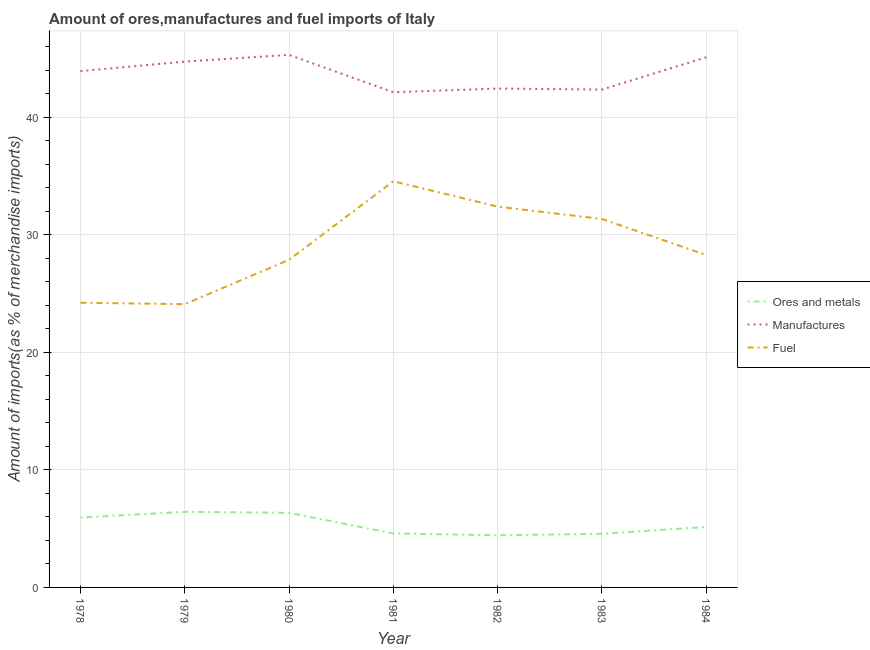How many different coloured lines are there?
Offer a terse response. 3. Is the number of lines equal to the number of legend labels?
Provide a short and direct response. Yes. What is the percentage of fuel imports in 1982?
Ensure brevity in your answer.  32.39. Across all years, what is the maximum percentage of fuel imports?
Keep it short and to the point. 34.54. Across all years, what is the minimum percentage of fuel imports?
Make the answer very short. 24.09. In which year was the percentage of fuel imports minimum?
Ensure brevity in your answer.  1979. What is the total percentage of manufactures imports in the graph?
Keep it short and to the point. 305.9. What is the difference between the percentage of manufactures imports in 1978 and that in 1979?
Your answer should be compact. -0.81. What is the difference between the percentage of manufactures imports in 1983 and the percentage of ores and metals imports in 1980?
Provide a succinct answer. 36. What is the average percentage of manufactures imports per year?
Offer a terse response. 43.7. In the year 1979, what is the difference between the percentage of ores and metals imports and percentage of manufactures imports?
Provide a short and direct response. -38.29. In how many years, is the percentage of manufactures imports greater than 6 %?
Give a very brief answer. 7. What is the ratio of the percentage of fuel imports in 1978 to that in 1982?
Provide a succinct answer. 0.75. Is the percentage of manufactures imports in 1980 less than that in 1982?
Your response must be concise. No. Is the difference between the percentage of ores and metals imports in 1979 and 1982 greater than the difference between the percentage of manufactures imports in 1979 and 1982?
Offer a very short reply. No. What is the difference between the highest and the second highest percentage of manufactures imports?
Provide a short and direct response. 0.2. What is the difference between the highest and the lowest percentage of manufactures imports?
Provide a short and direct response. 3.18. In how many years, is the percentage of fuel imports greater than the average percentage of fuel imports taken over all years?
Offer a very short reply. 3. Is it the case that in every year, the sum of the percentage of ores and metals imports and percentage of manufactures imports is greater than the percentage of fuel imports?
Make the answer very short. Yes. Is the percentage of manufactures imports strictly greater than the percentage of fuel imports over the years?
Your response must be concise. Yes. How many lines are there?
Ensure brevity in your answer.  3. What is the difference between two consecutive major ticks on the Y-axis?
Your answer should be very brief. 10. Are the values on the major ticks of Y-axis written in scientific E-notation?
Your answer should be compact. No. How many legend labels are there?
Ensure brevity in your answer.  3. What is the title of the graph?
Give a very brief answer. Amount of ores,manufactures and fuel imports of Italy. Does "Ages 65 and above" appear as one of the legend labels in the graph?
Your answer should be very brief. No. What is the label or title of the Y-axis?
Your response must be concise. Amount of imports(as % of merchandise imports). What is the Amount of imports(as % of merchandise imports) of Ores and metals in 1978?
Keep it short and to the point. 5.94. What is the Amount of imports(as % of merchandise imports) of Manufactures in 1978?
Offer a very short reply. 43.91. What is the Amount of imports(as % of merchandise imports) of Fuel in 1978?
Offer a terse response. 24.22. What is the Amount of imports(as % of merchandise imports) in Ores and metals in 1979?
Provide a succinct answer. 6.43. What is the Amount of imports(as % of merchandise imports) in Manufactures in 1979?
Your response must be concise. 44.72. What is the Amount of imports(as % of merchandise imports) of Fuel in 1979?
Keep it short and to the point. 24.09. What is the Amount of imports(as % of merchandise imports) of Ores and metals in 1980?
Your answer should be very brief. 6.34. What is the Amount of imports(as % of merchandise imports) of Manufactures in 1980?
Give a very brief answer. 45.29. What is the Amount of imports(as % of merchandise imports) of Fuel in 1980?
Ensure brevity in your answer.  27.86. What is the Amount of imports(as % of merchandise imports) of Ores and metals in 1981?
Provide a short and direct response. 4.59. What is the Amount of imports(as % of merchandise imports) in Manufactures in 1981?
Offer a very short reply. 42.11. What is the Amount of imports(as % of merchandise imports) in Fuel in 1981?
Offer a very short reply. 34.54. What is the Amount of imports(as % of merchandise imports) of Ores and metals in 1982?
Give a very brief answer. 4.43. What is the Amount of imports(as % of merchandise imports) in Manufactures in 1982?
Your answer should be very brief. 42.43. What is the Amount of imports(as % of merchandise imports) in Fuel in 1982?
Offer a very short reply. 32.39. What is the Amount of imports(as % of merchandise imports) in Ores and metals in 1983?
Your answer should be compact. 4.56. What is the Amount of imports(as % of merchandise imports) in Manufactures in 1983?
Your answer should be compact. 42.34. What is the Amount of imports(as % of merchandise imports) in Fuel in 1983?
Keep it short and to the point. 31.34. What is the Amount of imports(as % of merchandise imports) of Ores and metals in 1984?
Provide a succinct answer. 5.15. What is the Amount of imports(as % of merchandise imports) in Manufactures in 1984?
Your answer should be very brief. 45.09. What is the Amount of imports(as % of merchandise imports) in Fuel in 1984?
Your answer should be very brief. 28.27. Across all years, what is the maximum Amount of imports(as % of merchandise imports) of Ores and metals?
Provide a short and direct response. 6.43. Across all years, what is the maximum Amount of imports(as % of merchandise imports) in Manufactures?
Provide a succinct answer. 45.29. Across all years, what is the maximum Amount of imports(as % of merchandise imports) of Fuel?
Your answer should be compact. 34.54. Across all years, what is the minimum Amount of imports(as % of merchandise imports) in Ores and metals?
Your answer should be very brief. 4.43. Across all years, what is the minimum Amount of imports(as % of merchandise imports) in Manufactures?
Provide a succinct answer. 42.11. Across all years, what is the minimum Amount of imports(as % of merchandise imports) in Fuel?
Keep it short and to the point. 24.09. What is the total Amount of imports(as % of merchandise imports) of Ores and metals in the graph?
Your answer should be very brief. 37.44. What is the total Amount of imports(as % of merchandise imports) of Manufactures in the graph?
Your response must be concise. 305.9. What is the total Amount of imports(as % of merchandise imports) in Fuel in the graph?
Make the answer very short. 202.7. What is the difference between the Amount of imports(as % of merchandise imports) in Ores and metals in 1978 and that in 1979?
Provide a succinct answer. -0.49. What is the difference between the Amount of imports(as % of merchandise imports) in Manufactures in 1978 and that in 1979?
Your answer should be very brief. -0.81. What is the difference between the Amount of imports(as % of merchandise imports) in Fuel in 1978 and that in 1979?
Keep it short and to the point. 0.13. What is the difference between the Amount of imports(as % of merchandise imports) of Ores and metals in 1978 and that in 1980?
Provide a succinct answer. -0.4. What is the difference between the Amount of imports(as % of merchandise imports) in Manufactures in 1978 and that in 1980?
Offer a very short reply. -1.38. What is the difference between the Amount of imports(as % of merchandise imports) of Fuel in 1978 and that in 1980?
Your answer should be compact. -3.65. What is the difference between the Amount of imports(as % of merchandise imports) of Ores and metals in 1978 and that in 1981?
Ensure brevity in your answer.  1.35. What is the difference between the Amount of imports(as % of merchandise imports) of Manufactures in 1978 and that in 1981?
Provide a succinct answer. 1.8. What is the difference between the Amount of imports(as % of merchandise imports) in Fuel in 1978 and that in 1981?
Your answer should be compact. -10.33. What is the difference between the Amount of imports(as % of merchandise imports) in Ores and metals in 1978 and that in 1982?
Offer a very short reply. 1.51. What is the difference between the Amount of imports(as % of merchandise imports) of Manufactures in 1978 and that in 1982?
Give a very brief answer. 1.48. What is the difference between the Amount of imports(as % of merchandise imports) of Fuel in 1978 and that in 1982?
Your answer should be very brief. -8.17. What is the difference between the Amount of imports(as % of merchandise imports) in Ores and metals in 1978 and that in 1983?
Your answer should be very brief. 1.38. What is the difference between the Amount of imports(as % of merchandise imports) in Manufactures in 1978 and that in 1983?
Your response must be concise. 1.57. What is the difference between the Amount of imports(as % of merchandise imports) of Fuel in 1978 and that in 1983?
Keep it short and to the point. -7.12. What is the difference between the Amount of imports(as % of merchandise imports) in Ores and metals in 1978 and that in 1984?
Provide a succinct answer. 0.79. What is the difference between the Amount of imports(as % of merchandise imports) in Manufactures in 1978 and that in 1984?
Your response must be concise. -1.18. What is the difference between the Amount of imports(as % of merchandise imports) in Fuel in 1978 and that in 1984?
Make the answer very short. -4.06. What is the difference between the Amount of imports(as % of merchandise imports) of Ores and metals in 1979 and that in 1980?
Provide a succinct answer. 0.09. What is the difference between the Amount of imports(as % of merchandise imports) of Manufactures in 1979 and that in 1980?
Ensure brevity in your answer.  -0.57. What is the difference between the Amount of imports(as % of merchandise imports) in Fuel in 1979 and that in 1980?
Keep it short and to the point. -3.77. What is the difference between the Amount of imports(as % of merchandise imports) of Ores and metals in 1979 and that in 1981?
Give a very brief answer. 1.84. What is the difference between the Amount of imports(as % of merchandise imports) in Manufactures in 1979 and that in 1981?
Ensure brevity in your answer.  2.61. What is the difference between the Amount of imports(as % of merchandise imports) of Fuel in 1979 and that in 1981?
Provide a short and direct response. -10.45. What is the difference between the Amount of imports(as % of merchandise imports) of Ores and metals in 1979 and that in 1982?
Offer a very short reply. 2. What is the difference between the Amount of imports(as % of merchandise imports) in Manufactures in 1979 and that in 1982?
Offer a very short reply. 2.29. What is the difference between the Amount of imports(as % of merchandise imports) of Fuel in 1979 and that in 1982?
Your answer should be very brief. -8.3. What is the difference between the Amount of imports(as % of merchandise imports) of Ores and metals in 1979 and that in 1983?
Your answer should be very brief. 1.87. What is the difference between the Amount of imports(as % of merchandise imports) of Manufactures in 1979 and that in 1983?
Your response must be concise. 2.38. What is the difference between the Amount of imports(as % of merchandise imports) in Fuel in 1979 and that in 1983?
Offer a very short reply. -7.25. What is the difference between the Amount of imports(as % of merchandise imports) of Ores and metals in 1979 and that in 1984?
Your response must be concise. 1.28. What is the difference between the Amount of imports(as % of merchandise imports) in Manufactures in 1979 and that in 1984?
Your answer should be very brief. -0.37. What is the difference between the Amount of imports(as % of merchandise imports) in Fuel in 1979 and that in 1984?
Your response must be concise. -4.18. What is the difference between the Amount of imports(as % of merchandise imports) of Ores and metals in 1980 and that in 1981?
Your answer should be compact. 1.75. What is the difference between the Amount of imports(as % of merchandise imports) of Manufactures in 1980 and that in 1981?
Offer a terse response. 3.18. What is the difference between the Amount of imports(as % of merchandise imports) of Fuel in 1980 and that in 1981?
Offer a terse response. -6.68. What is the difference between the Amount of imports(as % of merchandise imports) in Ores and metals in 1980 and that in 1982?
Offer a very short reply. 1.91. What is the difference between the Amount of imports(as % of merchandise imports) of Manufactures in 1980 and that in 1982?
Provide a short and direct response. 2.87. What is the difference between the Amount of imports(as % of merchandise imports) of Fuel in 1980 and that in 1982?
Your response must be concise. -4.52. What is the difference between the Amount of imports(as % of merchandise imports) of Ores and metals in 1980 and that in 1983?
Your answer should be very brief. 1.78. What is the difference between the Amount of imports(as % of merchandise imports) in Manufactures in 1980 and that in 1983?
Give a very brief answer. 2.95. What is the difference between the Amount of imports(as % of merchandise imports) of Fuel in 1980 and that in 1983?
Your answer should be compact. -3.47. What is the difference between the Amount of imports(as % of merchandise imports) of Ores and metals in 1980 and that in 1984?
Make the answer very short. 1.2. What is the difference between the Amount of imports(as % of merchandise imports) in Manufactures in 1980 and that in 1984?
Provide a short and direct response. 0.2. What is the difference between the Amount of imports(as % of merchandise imports) in Fuel in 1980 and that in 1984?
Provide a short and direct response. -0.41. What is the difference between the Amount of imports(as % of merchandise imports) in Ores and metals in 1981 and that in 1982?
Make the answer very short. 0.16. What is the difference between the Amount of imports(as % of merchandise imports) of Manufactures in 1981 and that in 1982?
Provide a short and direct response. -0.31. What is the difference between the Amount of imports(as % of merchandise imports) of Fuel in 1981 and that in 1982?
Your answer should be very brief. 2.16. What is the difference between the Amount of imports(as % of merchandise imports) in Ores and metals in 1981 and that in 1983?
Ensure brevity in your answer.  0.03. What is the difference between the Amount of imports(as % of merchandise imports) in Manufactures in 1981 and that in 1983?
Your answer should be very brief. -0.23. What is the difference between the Amount of imports(as % of merchandise imports) in Fuel in 1981 and that in 1983?
Offer a very short reply. 3.21. What is the difference between the Amount of imports(as % of merchandise imports) of Ores and metals in 1981 and that in 1984?
Your answer should be compact. -0.55. What is the difference between the Amount of imports(as % of merchandise imports) in Manufactures in 1981 and that in 1984?
Keep it short and to the point. -2.98. What is the difference between the Amount of imports(as % of merchandise imports) in Fuel in 1981 and that in 1984?
Ensure brevity in your answer.  6.27. What is the difference between the Amount of imports(as % of merchandise imports) in Ores and metals in 1982 and that in 1983?
Offer a very short reply. -0.13. What is the difference between the Amount of imports(as % of merchandise imports) of Manufactures in 1982 and that in 1983?
Your answer should be very brief. 0.09. What is the difference between the Amount of imports(as % of merchandise imports) in Fuel in 1982 and that in 1983?
Your answer should be compact. 1.05. What is the difference between the Amount of imports(as % of merchandise imports) of Ores and metals in 1982 and that in 1984?
Provide a short and direct response. -0.71. What is the difference between the Amount of imports(as % of merchandise imports) in Manufactures in 1982 and that in 1984?
Your answer should be very brief. -2.66. What is the difference between the Amount of imports(as % of merchandise imports) of Fuel in 1982 and that in 1984?
Provide a short and direct response. 4.11. What is the difference between the Amount of imports(as % of merchandise imports) in Ores and metals in 1983 and that in 1984?
Offer a very short reply. -0.59. What is the difference between the Amount of imports(as % of merchandise imports) of Manufactures in 1983 and that in 1984?
Ensure brevity in your answer.  -2.75. What is the difference between the Amount of imports(as % of merchandise imports) in Fuel in 1983 and that in 1984?
Offer a terse response. 3.06. What is the difference between the Amount of imports(as % of merchandise imports) in Ores and metals in 1978 and the Amount of imports(as % of merchandise imports) in Manufactures in 1979?
Your response must be concise. -38.78. What is the difference between the Amount of imports(as % of merchandise imports) in Ores and metals in 1978 and the Amount of imports(as % of merchandise imports) in Fuel in 1979?
Provide a short and direct response. -18.15. What is the difference between the Amount of imports(as % of merchandise imports) of Manufactures in 1978 and the Amount of imports(as % of merchandise imports) of Fuel in 1979?
Offer a very short reply. 19.82. What is the difference between the Amount of imports(as % of merchandise imports) in Ores and metals in 1978 and the Amount of imports(as % of merchandise imports) in Manufactures in 1980?
Offer a very short reply. -39.35. What is the difference between the Amount of imports(as % of merchandise imports) in Ores and metals in 1978 and the Amount of imports(as % of merchandise imports) in Fuel in 1980?
Your answer should be compact. -21.92. What is the difference between the Amount of imports(as % of merchandise imports) in Manufactures in 1978 and the Amount of imports(as % of merchandise imports) in Fuel in 1980?
Give a very brief answer. 16.05. What is the difference between the Amount of imports(as % of merchandise imports) in Ores and metals in 1978 and the Amount of imports(as % of merchandise imports) in Manufactures in 1981?
Your response must be concise. -36.17. What is the difference between the Amount of imports(as % of merchandise imports) in Ores and metals in 1978 and the Amount of imports(as % of merchandise imports) in Fuel in 1981?
Offer a very short reply. -28.6. What is the difference between the Amount of imports(as % of merchandise imports) of Manufactures in 1978 and the Amount of imports(as % of merchandise imports) of Fuel in 1981?
Ensure brevity in your answer.  9.37. What is the difference between the Amount of imports(as % of merchandise imports) in Ores and metals in 1978 and the Amount of imports(as % of merchandise imports) in Manufactures in 1982?
Your answer should be very brief. -36.49. What is the difference between the Amount of imports(as % of merchandise imports) in Ores and metals in 1978 and the Amount of imports(as % of merchandise imports) in Fuel in 1982?
Make the answer very short. -26.45. What is the difference between the Amount of imports(as % of merchandise imports) of Manufactures in 1978 and the Amount of imports(as % of merchandise imports) of Fuel in 1982?
Your answer should be very brief. 11.52. What is the difference between the Amount of imports(as % of merchandise imports) of Ores and metals in 1978 and the Amount of imports(as % of merchandise imports) of Manufactures in 1983?
Give a very brief answer. -36.4. What is the difference between the Amount of imports(as % of merchandise imports) of Ores and metals in 1978 and the Amount of imports(as % of merchandise imports) of Fuel in 1983?
Ensure brevity in your answer.  -25.4. What is the difference between the Amount of imports(as % of merchandise imports) of Manufactures in 1978 and the Amount of imports(as % of merchandise imports) of Fuel in 1983?
Give a very brief answer. 12.57. What is the difference between the Amount of imports(as % of merchandise imports) in Ores and metals in 1978 and the Amount of imports(as % of merchandise imports) in Manufactures in 1984?
Provide a short and direct response. -39.15. What is the difference between the Amount of imports(as % of merchandise imports) in Ores and metals in 1978 and the Amount of imports(as % of merchandise imports) in Fuel in 1984?
Offer a very short reply. -22.33. What is the difference between the Amount of imports(as % of merchandise imports) in Manufactures in 1978 and the Amount of imports(as % of merchandise imports) in Fuel in 1984?
Provide a short and direct response. 15.64. What is the difference between the Amount of imports(as % of merchandise imports) of Ores and metals in 1979 and the Amount of imports(as % of merchandise imports) of Manufactures in 1980?
Provide a succinct answer. -38.86. What is the difference between the Amount of imports(as % of merchandise imports) of Ores and metals in 1979 and the Amount of imports(as % of merchandise imports) of Fuel in 1980?
Ensure brevity in your answer.  -21.43. What is the difference between the Amount of imports(as % of merchandise imports) in Manufactures in 1979 and the Amount of imports(as % of merchandise imports) in Fuel in 1980?
Offer a terse response. 16.86. What is the difference between the Amount of imports(as % of merchandise imports) in Ores and metals in 1979 and the Amount of imports(as % of merchandise imports) in Manufactures in 1981?
Provide a short and direct response. -35.68. What is the difference between the Amount of imports(as % of merchandise imports) in Ores and metals in 1979 and the Amount of imports(as % of merchandise imports) in Fuel in 1981?
Offer a terse response. -28.11. What is the difference between the Amount of imports(as % of merchandise imports) of Manufactures in 1979 and the Amount of imports(as % of merchandise imports) of Fuel in 1981?
Provide a short and direct response. 10.18. What is the difference between the Amount of imports(as % of merchandise imports) in Ores and metals in 1979 and the Amount of imports(as % of merchandise imports) in Manufactures in 1982?
Ensure brevity in your answer.  -36. What is the difference between the Amount of imports(as % of merchandise imports) of Ores and metals in 1979 and the Amount of imports(as % of merchandise imports) of Fuel in 1982?
Provide a succinct answer. -25.96. What is the difference between the Amount of imports(as % of merchandise imports) in Manufactures in 1979 and the Amount of imports(as % of merchandise imports) in Fuel in 1982?
Provide a succinct answer. 12.33. What is the difference between the Amount of imports(as % of merchandise imports) of Ores and metals in 1979 and the Amount of imports(as % of merchandise imports) of Manufactures in 1983?
Keep it short and to the point. -35.91. What is the difference between the Amount of imports(as % of merchandise imports) in Ores and metals in 1979 and the Amount of imports(as % of merchandise imports) in Fuel in 1983?
Your response must be concise. -24.91. What is the difference between the Amount of imports(as % of merchandise imports) in Manufactures in 1979 and the Amount of imports(as % of merchandise imports) in Fuel in 1983?
Provide a succinct answer. 13.38. What is the difference between the Amount of imports(as % of merchandise imports) of Ores and metals in 1979 and the Amount of imports(as % of merchandise imports) of Manufactures in 1984?
Your response must be concise. -38.66. What is the difference between the Amount of imports(as % of merchandise imports) of Ores and metals in 1979 and the Amount of imports(as % of merchandise imports) of Fuel in 1984?
Keep it short and to the point. -21.84. What is the difference between the Amount of imports(as % of merchandise imports) in Manufactures in 1979 and the Amount of imports(as % of merchandise imports) in Fuel in 1984?
Provide a succinct answer. 16.45. What is the difference between the Amount of imports(as % of merchandise imports) of Ores and metals in 1980 and the Amount of imports(as % of merchandise imports) of Manufactures in 1981?
Keep it short and to the point. -35.77. What is the difference between the Amount of imports(as % of merchandise imports) in Ores and metals in 1980 and the Amount of imports(as % of merchandise imports) in Fuel in 1981?
Ensure brevity in your answer.  -28.2. What is the difference between the Amount of imports(as % of merchandise imports) of Manufactures in 1980 and the Amount of imports(as % of merchandise imports) of Fuel in 1981?
Provide a short and direct response. 10.75. What is the difference between the Amount of imports(as % of merchandise imports) of Ores and metals in 1980 and the Amount of imports(as % of merchandise imports) of Manufactures in 1982?
Make the answer very short. -36.09. What is the difference between the Amount of imports(as % of merchandise imports) of Ores and metals in 1980 and the Amount of imports(as % of merchandise imports) of Fuel in 1982?
Make the answer very short. -26.04. What is the difference between the Amount of imports(as % of merchandise imports) of Manufactures in 1980 and the Amount of imports(as % of merchandise imports) of Fuel in 1982?
Provide a succinct answer. 12.91. What is the difference between the Amount of imports(as % of merchandise imports) of Ores and metals in 1980 and the Amount of imports(as % of merchandise imports) of Manufactures in 1983?
Keep it short and to the point. -36. What is the difference between the Amount of imports(as % of merchandise imports) of Ores and metals in 1980 and the Amount of imports(as % of merchandise imports) of Fuel in 1983?
Ensure brevity in your answer.  -24.99. What is the difference between the Amount of imports(as % of merchandise imports) in Manufactures in 1980 and the Amount of imports(as % of merchandise imports) in Fuel in 1983?
Keep it short and to the point. 13.96. What is the difference between the Amount of imports(as % of merchandise imports) in Ores and metals in 1980 and the Amount of imports(as % of merchandise imports) in Manufactures in 1984?
Make the answer very short. -38.75. What is the difference between the Amount of imports(as % of merchandise imports) in Ores and metals in 1980 and the Amount of imports(as % of merchandise imports) in Fuel in 1984?
Make the answer very short. -21.93. What is the difference between the Amount of imports(as % of merchandise imports) of Manufactures in 1980 and the Amount of imports(as % of merchandise imports) of Fuel in 1984?
Your answer should be compact. 17.02. What is the difference between the Amount of imports(as % of merchandise imports) of Ores and metals in 1981 and the Amount of imports(as % of merchandise imports) of Manufactures in 1982?
Your answer should be compact. -37.84. What is the difference between the Amount of imports(as % of merchandise imports) of Ores and metals in 1981 and the Amount of imports(as % of merchandise imports) of Fuel in 1982?
Provide a short and direct response. -27.79. What is the difference between the Amount of imports(as % of merchandise imports) in Manufactures in 1981 and the Amount of imports(as % of merchandise imports) in Fuel in 1982?
Ensure brevity in your answer.  9.73. What is the difference between the Amount of imports(as % of merchandise imports) of Ores and metals in 1981 and the Amount of imports(as % of merchandise imports) of Manufactures in 1983?
Make the answer very short. -37.75. What is the difference between the Amount of imports(as % of merchandise imports) in Ores and metals in 1981 and the Amount of imports(as % of merchandise imports) in Fuel in 1983?
Keep it short and to the point. -26.75. What is the difference between the Amount of imports(as % of merchandise imports) of Manufactures in 1981 and the Amount of imports(as % of merchandise imports) of Fuel in 1983?
Keep it short and to the point. 10.78. What is the difference between the Amount of imports(as % of merchandise imports) in Ores and metals in 1981 and the Amount of imports(as % of merchandise imports) in Manufactures in 1984?
Give a very brief answer. -40.5. What is the difference between the Amount of imports(as % of merchandise imports) in Ores and metals in 1981 and the Amount of imports(as % of merchandise imports) in Fuel in 1984?
Your answer should be very brief. -23.68. What is the difference between the Amount of imports(as % of merchandise imports) of Manufactures in 1981 and the Amount of imports(as % of merchandise imports) of Fuel in 1984?
Offer a very short reply. 13.84. What is the difference between the Amount of imports(as % of merchandise imports) of Ores and metals in 1982 and the Amount of imports(as % of merchandise imports) of Manufactures in 1983?
Your answer should be compact. -37.91. What is the difference between the Amount of imports(as % of merchandise imports) in Ores and metals in 1982 and the Amount of imports(as % of merchandise imports) in Fuel in 1983?
Provide a succinct answer. -26.9. What is the difference between the Amount of imports(as % of merchandise imports) in Manufactures in 1982 and the Amount of imports(as % of merchandise imports) in Fuel in 1983?
Keep it short and to the point. 11.09. What is the difference between the Amount of imports(as % of merchandise imports) in Ores and metals in 1982 and the Amount of imports(as % of merchandise imports) in Manufactures in 1984?
Your answer should be compact. -40.66. What is the difference between the Amount of imports(as % of merchandise imports) in Ores and metals in 1982 and the Amount of imports(as % of merchandise imports) in Fuel in 1984?
Offer a terse response. -23.84. What is the difference between the Amount of imports(as % of merchandise imports) in Manufactures in 1982 and the Amount of imports(as % of merchandise imports) in Fuel in 1984?
Offer a terse response. 14.16. What is the difference between the Amount of imports(as % of merchandise imports) in Ores and metals in 1983 and the Amount of imports(as % of merchandise imports) in Manufactures in 1984?
Give a very brief answer. -40.53. What is the difference between the Amount of imports(as % of merchandise imports) of Ores and metals in 1983 and the Amount of imports(as % of merchandise imports) of Fuel in 1984?
Your answer should be compact. -23.71. What is the difference between the Amount of imports(as % of merchandise imports) in Manufactures in 1983 and the Amount of imports(as % of merchandise imports) in Fuel in 1984?
Give a very brief answer. 14.07. What is the average Amount of imports(as % of merchandise imports) of Ores and metals per year?
Your answer should be very brief. 5.35. What is the average Amount of imports(as % of merchandise imports) in Manufactures per year?
Ensure brevity in your answer.  43.7. What is the average Amount of imports(as % of merchandise imports) of Fuel per year?
Offer a very short reply. 28.96. In the year 1978, what is the difference between the Amount of imports(as % of merchandise imports) of Ores and metals and Amount of imports(as % of merchandise imports) of Manufactures?
Keep it short and to the point. -37.97. In the year 1978, what is the difference between the Amount of imports(as % of merchandise imports) of Ores and metals and Amount of imports(as % of merchandise imports) of Fuel?
Your response must be concise. -18.27. In the year 1978, what is the difference between the Amount of imports(as % of merchandise imports) in Manufactures and Amount of imports(as % of merchandise imports) in Fuel?
Give a very brief answer. 19.69. In the year 1979, what is the difference between the Amount of imports(as % of merchandise imports) of Ores and metals and Amount of imports(as % of merchandise imports) of Manufactures?
Offer a terse response. -38.29. In the year 1979, what is the difference between the Amount of imports(as % of merchandise imports) of Ores and metals and Amount of imports(as % of merchandise imports) of Fuel?
Provide a succinct answer. -17.66. In the year 1979, what is the difference between the Amount of imports(as % of merchandise imports) in Manufactures and Amount of imports(as % of merchandise imports) in Fuel?
Your answer should be very brief. 20.63. In the year 1980, what is the difference between the Amount of imports(as % of merchandise imports) of Ores and metals and Amount of imports(as % of merchandise imports) of Manufactures?
Your response must be concise. -38.95. In the year 1980, what is the difference between the Amount of imports(as % of merchandise imports) of Ores and metals and Amount of imports(as % of merchandise imports) of Fuel?
Offer a terse response. -21.52. In the year 1980, what is the difference between the Amount of imports(as % of merchandise imports) in Manufactures and Amount of imports(as % of merchandise imports) in Fuel?
Offer a terse response. 17.43. In the year 1981, what is the difference between the Amount of imports(as % of merchandise imports) in Ores and metals and Amount of imports(as % of merchandise imports) in Manufactures?
Give a very brief answer. -37.52. In the year 1981, what is the difference between the Amount of imports(as % of merchandise imports) of Ores and metals and Amount of imports(as % of merchandise imports) of Fuel?
Offer a very short reply. -29.95. In the year 1981, what is the difference between the Amount of imports(as % of merchandise imports) of Manufactures and Amount of imports(as % of merchandise imports) of Fuel?
Make the answer very short. 7.57. In the year 1982, what is the difference between the Amount of imports(as % of merchandise imports) in Ores and metals and Amount of imports(as % of merchandise imports) in Manufactures?
Provide a succinct answer. -38. In the year 1982, what is the difference between the Amount of imports(as % of merchandise imports) of Ores and metals and Amount of imports(as % of merchandise imports) of Fuel?
Offer a terse response. -27.95. In the year 1982, what is the difference between the Amount of imports(as % of merchandise imports) of Manufactures and Amount of imports(as % of merchandise imports) of Fuel?
Make the answer very short. 10.04. In the year 1983, what is the difference between the Amount of imports(as % of merchandise imports) of Ores and metals and Amount of imports(as % of merchandise imports) of Manufactures?
Your answer should be compact. -37.78. In the year 1983, what is the difference between the Amount of imports(as % of merchandise imports) of Ores and metals and Amount of imports(as % of merchandise imports) of Fuel?
Your answer should be compact. -26.78. In the year 1983, what is the difference between the Amount of imports(as % of merchandise imports) in Manufactures and Amount of imports(as % of merchandise imports) in Fuel?
Make the answer very short. 11.01. In the year 1984, what is the difference between the Amount of imports(as % of merchandise imports) in Ores and metals and Amount of imports(as % of merchandise imports) in Manufactures?
Provide a succinct answer. -39.94. In the year 1984, what is the difference between the Amount of imports(as % of merchandise imports) in Ores and metals and Amount of imports(as % of merchandise imports) in Fuel?
Your answer should be very brief. -23.13. In the year 1984, what is the difference between the Amount of imports(as % of merchandise imports) in Manufactures and Amount of imports(as % of merchandise imports) in Fuel?
Provide a short and direct response. 16.82. What is the ratio of the Amount of imports(as % of merchandise imports) of Ores and metals in 1978 to that in 1979?
Your response must be concise. 0.92. What is the ratio of the Amount of imports(as % of merchandise imports) of Manufactures in 1978 to that in 1979?
Make the answer very short. 0.98. What is the ratio of the Amount of imports(as % of merchandise imports) of Fuel in 1978 to that in 1979?
Offer a very short reply. 1.01. What is the ratio of the Amount of imports(as % of merchandise imports) of Ores and metals in 1978 to that in 1980?
Give a very brief answer. 0.94. What is the ratio of the Amount of imports(as % of merchandise imports) in Manufactures in 1978 to that in 1980?
Make the answer very short. 0.97. What is the ratio of the Amount of imports(as % of merchandise imports) in Fuel in 1978 to that in 1980?
Make the answer very short. 0.87. What is the ratio of the Amount of imports(as % of merchandise imports) of Ores and metals in 1978 to that in 1981?
Your response must be concise. 1.29. What is the ratio of the Amount of imports(as % of merchandise imports) in Manufactures in 1978 to that in 1981?
Your response must be concise. 1.04. What is the ratio of the Amount of imports(as % of merchandise imports) of Fuel in 1978 to that in 1981?
Your answer should be very brief. 0.7. What is the ratio of the Amount of imports(as % of merchandise imports) of Ores and metals in 1978 to that in 1982?
Your response must be concise. 1.34. What is the ratio of the Amount of imports(as % of merchandise imports) of Manufactures in 1978 to that in 1982?
Offer a terse response. 1.03. What is the ratio of the Amount of imports(as % of merchandise imports) in Fuel in 1978 to that in 1982?
Provide a short and direct response. 0.75. What is the ratio of the Amount of imports(as % of merchandise imports) of Ores and metals in 1978 to that in 1983?
Your answer should be very brief. 1.3. What is the ratio of the Amount of imports(as % of merchandise imports) in Manufactures in 1978 to that in 1983?
Keep it short and to the point. 1.04. What is the ratio of the Amount of imports(as % of merchandise imports) of Fuel in 1978 to that in 1983?
Your response must be concise. 0.77. What is the ratio of the Amount of imports(as % of merchandise imports) in Ores and metals in 1978 to that in 1984?
Offer a terse response. 1.15. What is the ratio of the Amount of imports(as % of merchandise imports) in Manufactures in 1978 to that in 1984?
Your response must be concise. 0.97. What is the ratio of the Amount of imports(as % of merchandise imports) of Fuel in 1978 to that in 1984?
Provide a short and direct response. 0.86. What is the ratio of the Amount of imports(as % of merchandise imports) in Ores and metals in 1979 to that in 1980?
Provide a succinct answer. 1.01. What is the ratio of the Amount of imports(as % of merchandise imports) of Manufactures in 1979 to that in 1980?
Ensure brevity in your answer.  0.99. What is the ratio of the Amount of imports(as % of merchandise imports) of Fuel in 1979 to that in 1980?
Your answer should be very brief. 0.86. What is the ratio of the Amount of imports(as % of merchandise imports) of Ores and metals in 1979 to that in 1981?
Keep it short and to the point. 1.4. What is the ratio of the Amount of imports(as % of merchandise imports) in Manufactures in 1979 to that in 1981?
Offer a very short reply. 1.06. What is the ratio of the Amount of imports(as % of merchandise imports) in Fuel in 1979 to that in 1981?
Your answer should be very brief. 0.7. What is the ratio of the Amount of imports(as % of merchandise imports) in Ores and metals in 1979 to that in 1982?
Provide a short and direct response. 1.45. What is the ratio of the Amount of imports(as % of merchandise imports) of Manufactures in 1979 to that in 1982?
Your response must be concise. 1.05. What is the ratio of the Amount of imports(as % of merchandise imports) in Fuel in 1979 to that in 1982?
Offer a terse response. 0.74. What is the ratio of the Amount of imports(as % of merchandise imports) in Ores and metals in 1979 to that in 1983?
Your answer should be compact. 1.41. What is the ratio of the Amount of imports(as % of merchandise imports) of Manufactures in 1979 to that in 1983?
Offer a terse response. 1.06. What is the ratio of the Amount of imports(as % of merchandise imports) in Fuel in 1979 to that in 1983?
Make the answer very short. 0.77. What is the ratio of the Amount of imports(as % of merchandise imports) of Ores and metals in 1979 to that in 1984?
Make the answer very short. 1.25. What is the ratio of the Amount of imports(as % of merchandise imports) in Fuel in 1979 to that in 1984?
Make the answer very short. 0.85. What is the ratio of the Amount of imports(as % of merchandise imports) of Ores and metals in 1980 to that in 1981?
Your answer should be very brief. 1.38. What is the ratio of the Amount of imports(as % of merchandise imports) in Manufactures in 1980 to that in 1981?
Your answer should be compact. 1.08. What is the ratio of the Amount of imports(as % of merchandise imports) in Fuel in 1980 to that in 1981?
Make the answer very short. 0.81. What is the ratio of the Amount of imports(as % of merchandise imports) in Ores and metals in 1980 to that in 1982?
Make the answer very short. 1.43. What is the ratio of the Amount of imports(as % of merchandise imports) of Manufactures in 1980 to that in 1982?
Your answer should be very brief. 1.07. What is the ratio of the Amount of imports(as % of merchandise imports) of Fuel in 1980 to that in 1982?
Your response must be concise. 0.86. What is the ratio of the Amount of imports(as % of merchandise imports) of Ores and metals in 1980 to that in 1983?
Your answer should be very brief. 1.39. What is the ratio of the Amount of imports(as % of merchandise imports) in Manufactures in 1980 to that in 1983?
Your response must be concise. 1.07. What is the ratio of the Amount of imports(as % of merchandise imports) in Fuel in 1980 to that in 1983?
Make the answer very short. 0.89. What is the ratio of the Amount of imports(as % of merchandise imports) of Ores and metals in 1980 to that in 1984?
Offer a very short reply. 1.23. What is the ratio of the Amount of imports(as % of merchandise imports) in Fuel in 1980 to that in 1984?
Offer a very short reply. 0.99. What is the ratio of the Amount of imports(as % of merchandise imports) in Ores and metals in 1981 to that in 1982?
Provide a short and direct response. 1.04. What is the ratio of the Amount of imports(as % of merchandise imports) of Fuel in 1981 to that in 1982?
Provide a short and direct response. 1.07. What is the ratio of the Amount of imports(as % of merchandise imports) of Ores and metals in 1981 to that in 1983?
Keep it short and to the point. 1.01. What is the ratio of the Amount of imports(as % of merchandise imports) of Manufactures in 1981 to that in 1983?
Keep it short and to the point. 0.99. What is the ratio of the Amount of imports(as % of merchandise imports) in Fuel in 1981 to that in 1983?
Keep it short and to the point. 1.1. What is the ratio of the Amount of imports(as % of merchandise imports) of Ores and metals in 1981 to that in 1984?
Ensure brevity in your answer.  0.89. What is the ratio of the Amount of imports(as % of merchandise imports) in Manufactures in 1981 to that in 1984?
Make the answer very short. 0.93. What is the ratio of the Amount of imports(as % of merchandise imports) of Fuel in 1981 to that in 1984?
Your answer should be compact. 1.22. What is the ratio of the Amount of imports(as % of merchandise imports) of Ores and metals in 1982 to that in 1983?
Offer a terse response. 0.97. What is the ratio of the Amount of imports(as % of merchandise imports) of Manufactures in 1982 to that in 1983?
Give a very brief answer. 1. What is the ratio of the Amount of imports(as % of merchandise imports) of Fuel in 1982 to that in 1983?
Give a very brief answer. 1.03. What is the ratio of the Amount of imports(as % of merchandise imports) in Ores and metals in 1982 to that in 1984?
Provide a short and direct response. 0.86. What is the ratio of the Amount of imports(as % of merchandise imports) in Manufactures in 1982 to that in 1984?
Make the answer very short. 0.94. What is the ratio of the Amount of imports(as % of merchandise imports) in Fuel in 1982 to that in 1984?
Make the answer very short. 1.15. What is the ratio of the Amount of imports(as % of merchandise imports) of Ores and metals in 1983 to that in 1984?
Your answer should be very brief. 0.89. What is the ratio of the Amount of imports(as % of merchandise imports) in Manufactures in 1983 to that in 1984?
Offer a terse response. 0.94. What is the ratio of the Amount of imports(as % of merchandise imports) in Fuel in 1983 to that in 1984?
Your response must be concise. 1.11. What is the difference between the highest and the second highest Amount of imports(as % of merchandise imports) in Ores and metals?
Provide a short and direct response. 0.09. What is the difference between the highest and the second highest Amount of imports(as % of merchandise imports) in Manufactures?
Give a very brief answer. 0.2. What is the difference between the highest and the second highest Amount of imports(as % of merchandise imports) of Fuel?
Give a very brief answer. 2.16. What is the difference between the highest and the lowest Amount of imports(as % of merchandise imports) in Ores and metals?
Keep it short and to the point. 2. What is the difference between the highest and the lowest Amount of imports(as % of merchandise imports) in Manufactures?
Your answer should be compact. 3.18. What is the difference between the highest and the lowest Amount of imports(as % of merchandise imports) in Fuel?
Your response must be concise. 10.45. 